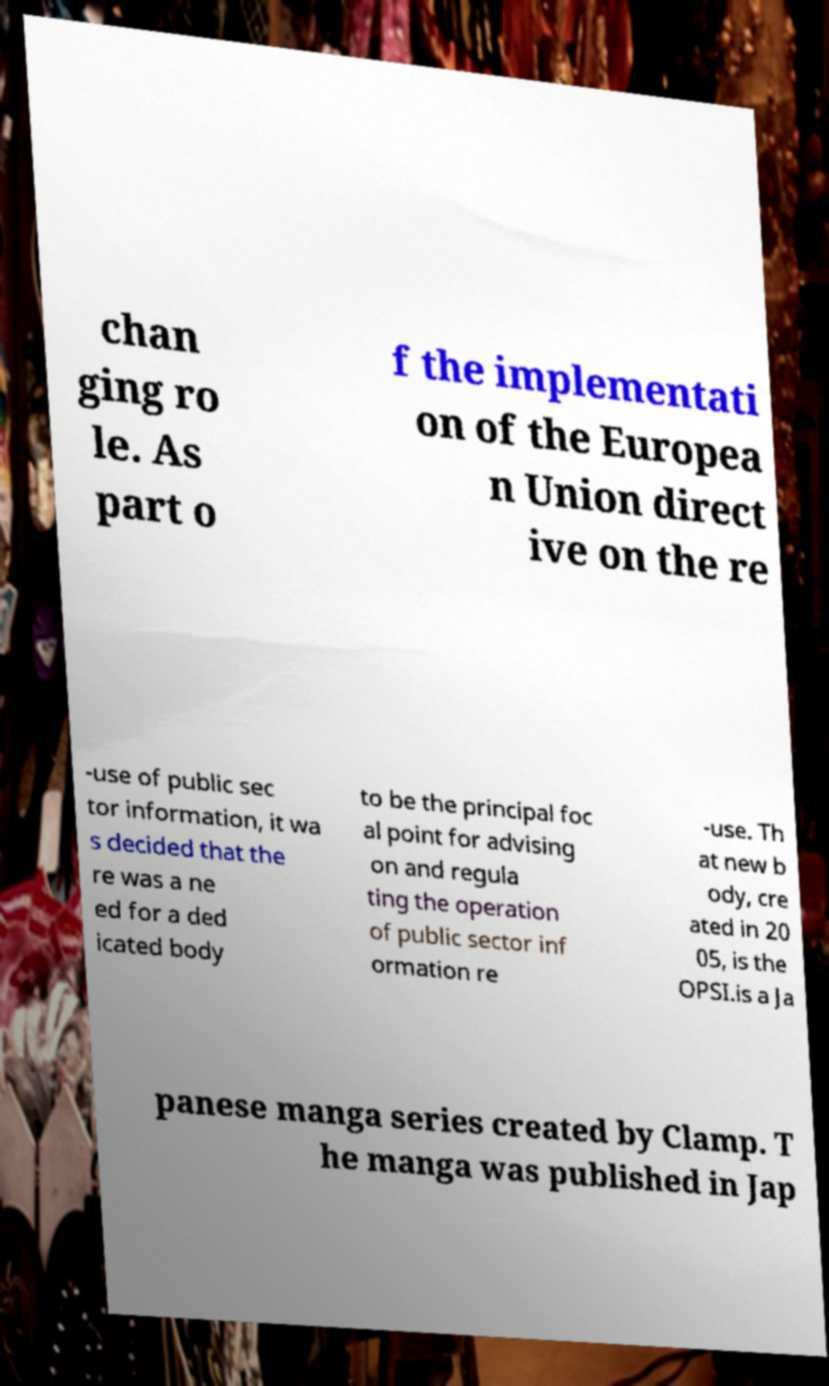For documentation purposes, I need the text within this image transcribed. Could you provide that? chan ging ro le. As part o f the implementati on of the Europea n Union direct ive on the re -use of public sec tor information, it wa s decided that the re was a ne ed for a ded icated body to be the principal foc al point for advising on and regula ting the operation of public sector inf ormation re -use. Th at new b ody, cre ated in 20 05, is the OPSI.is a Ja panese manga series created by Clamp. T he manga was published in Jap 